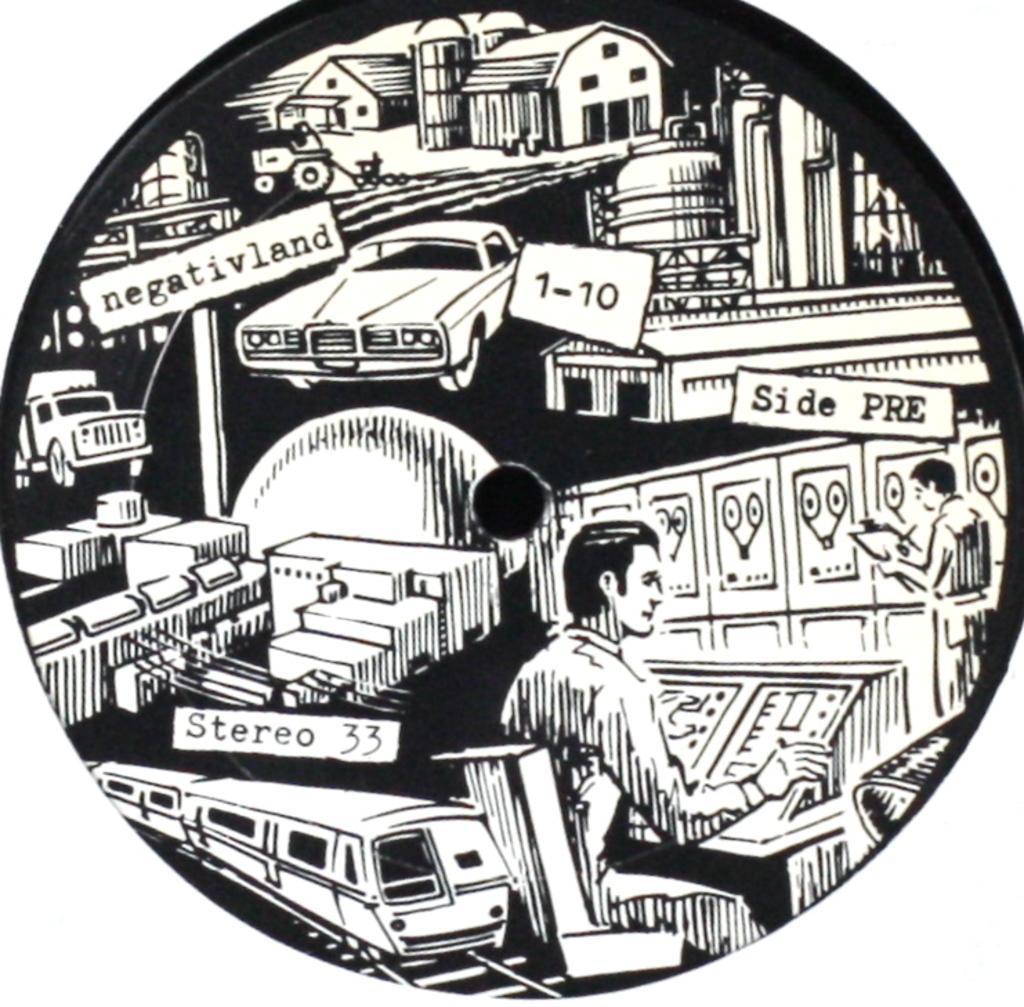How would you summarize this image in a sentence or two? As we can see in the image there is a drawing of a car, houses, two people, train, railway track and a truck. 